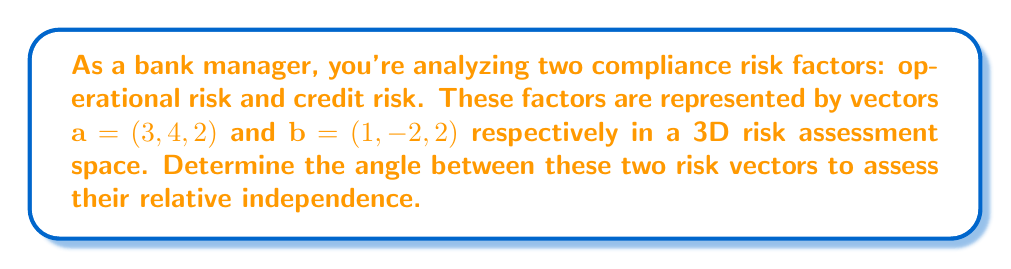Help me with this question. To find the angle between two vectors, we can use the dot product formula:

$$\cos \theta = \frac{\mathbf{a} \cdot \mathbf{b}}{|\mathbf{a}||\mathbf{b}|}$$

Where $\theta$ is the angle between the vectors, $\mathbf{a} \cdot \mathbf{b}$ is the dot product, and $|\mathbf{a}|$ and $|\mathbf{b}|$ are the magnitudes of the vectors.

Step 1: Calculate the dot product $\mathbf{a} \cdot \mathbf{b}$
$$\mathbf{a} \cdot \mathbf{b} = (3)(1) + (4)(-2) + (2)(2) = 3 - 8 + 4 = -1$$

Step 2: Calculate the magnitudes of the vectors
$$|\mathbf{a}| = \sqrt{3^2 + 4^2 + 2^2} = \sqrt{9 + 16 + 4} = \sqrt{29}$$
$$|\mathbf{b}| = \sqrt{1^2 + (-2)^2 + 2^2} = \sqrt{1 + 4 + 4} = 3$$

Step 3: Apply the dot product formula
$$\cos \theta = \frac{-1}{(\sqrt{29})(3)}$$

Step 4: Calculate the angle using the inverse cosine (arccos) function
$$\theta = \arccos\left(\frac{-1}{(\sqrt{29})(3)}\right)$$

Step 5: Convert to degrees
$$\theta = \arccos\left(\frac{-1}{(\sqrt{29})(3)}\right) \cdot \frac{180°}{\pi}$$
Answer: $\theta \approx 96.88°$ 